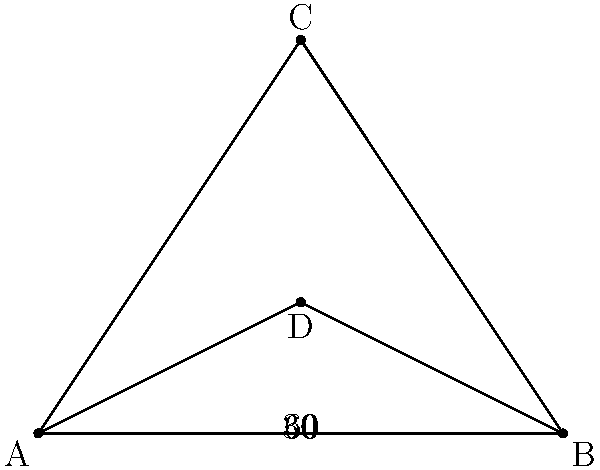In an urban environment, a traffic camera is positioned at point C, overlooking an intersection represented by point D. The camera's field of view is bounded by points A and B. Given that angle ADB is 90°, angle ACD is 30°, and angle BCD is 60°, what is the optimal viewing angle (angle ADB) for the traffic camera to capture the maximum area of the intersection while minimizing blind spots? To determine the optimal viewing angle for the traffic camera, we need to follow these steps:

1) First, we need to understand that the optimal viewing angle should balance between capturing a wide area and maintaining sufficient detail.

2) In this scenario, we are given a right-angled triangle ADB, where:
   - Angle ADB = 90°
   - Angle ACD = 30°
   - Angle BCD = 60°

3) We can deduce that triangle ACD is a 30-60-90 triangle, and triangle BCD is an equilateral triangle.

4) In a 30-60-90 triangle, if we denote the shortest side as x, then:
   - The hypotenuse is 2x
   - The middle side is $x\sqrt{3}$

5) In an equilateral triangle, all sides are equal and all angles are 60°.

6) Given these properties, we can conclude that:
   - AD = x
   - BD = $x\sqrt{3}$
   - CD = 2x

7) The viewing angle ACD is already given as 30°, which is generally considered a good minimum angle for traffic cameras to capture sufficient detail.

8) The total viewing angle ACB is 90° (30° + 60°), which provides a wide field of view without excessive distortion at the edges.

9) This configuration allows the camera to capture both the immediate area of the intersection (with the 30° angle) and a wider view of approaching traffic (with the additional 60° angle).

Therefore, the optimal viewing angle (angle ACB) for the traffic camera is 90°, as it provides a balance between detail and coverage.
Answer: 90° 